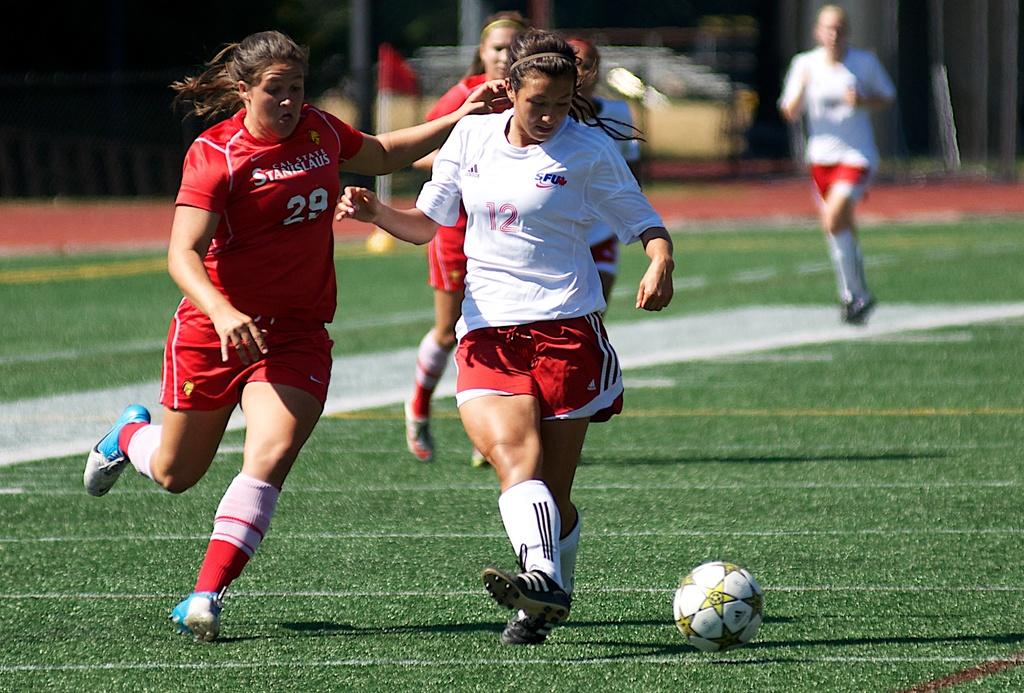What college does number 29 play for?
Provide a short and direct response. Cal state. 